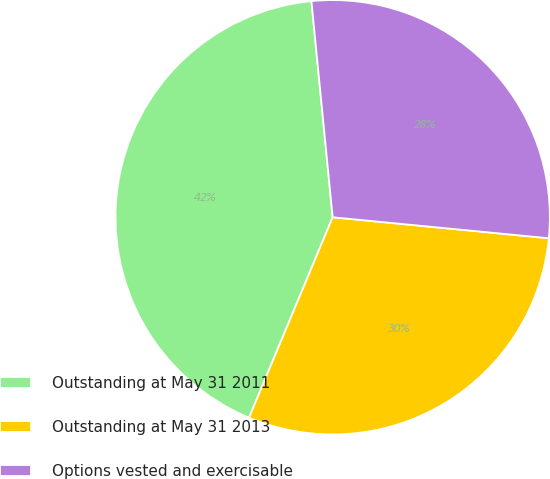<chart> <loc_0><loc_0><loc_500><loc_500><pie_chart><fcel>Outstanding at May 31 2011<fcel>Outstanding at May 31 2013<fcel>Options vested and exercisable<nl><fcel>42.15%<fcel>29.75%<fcel>28.1%<nl></chart> 